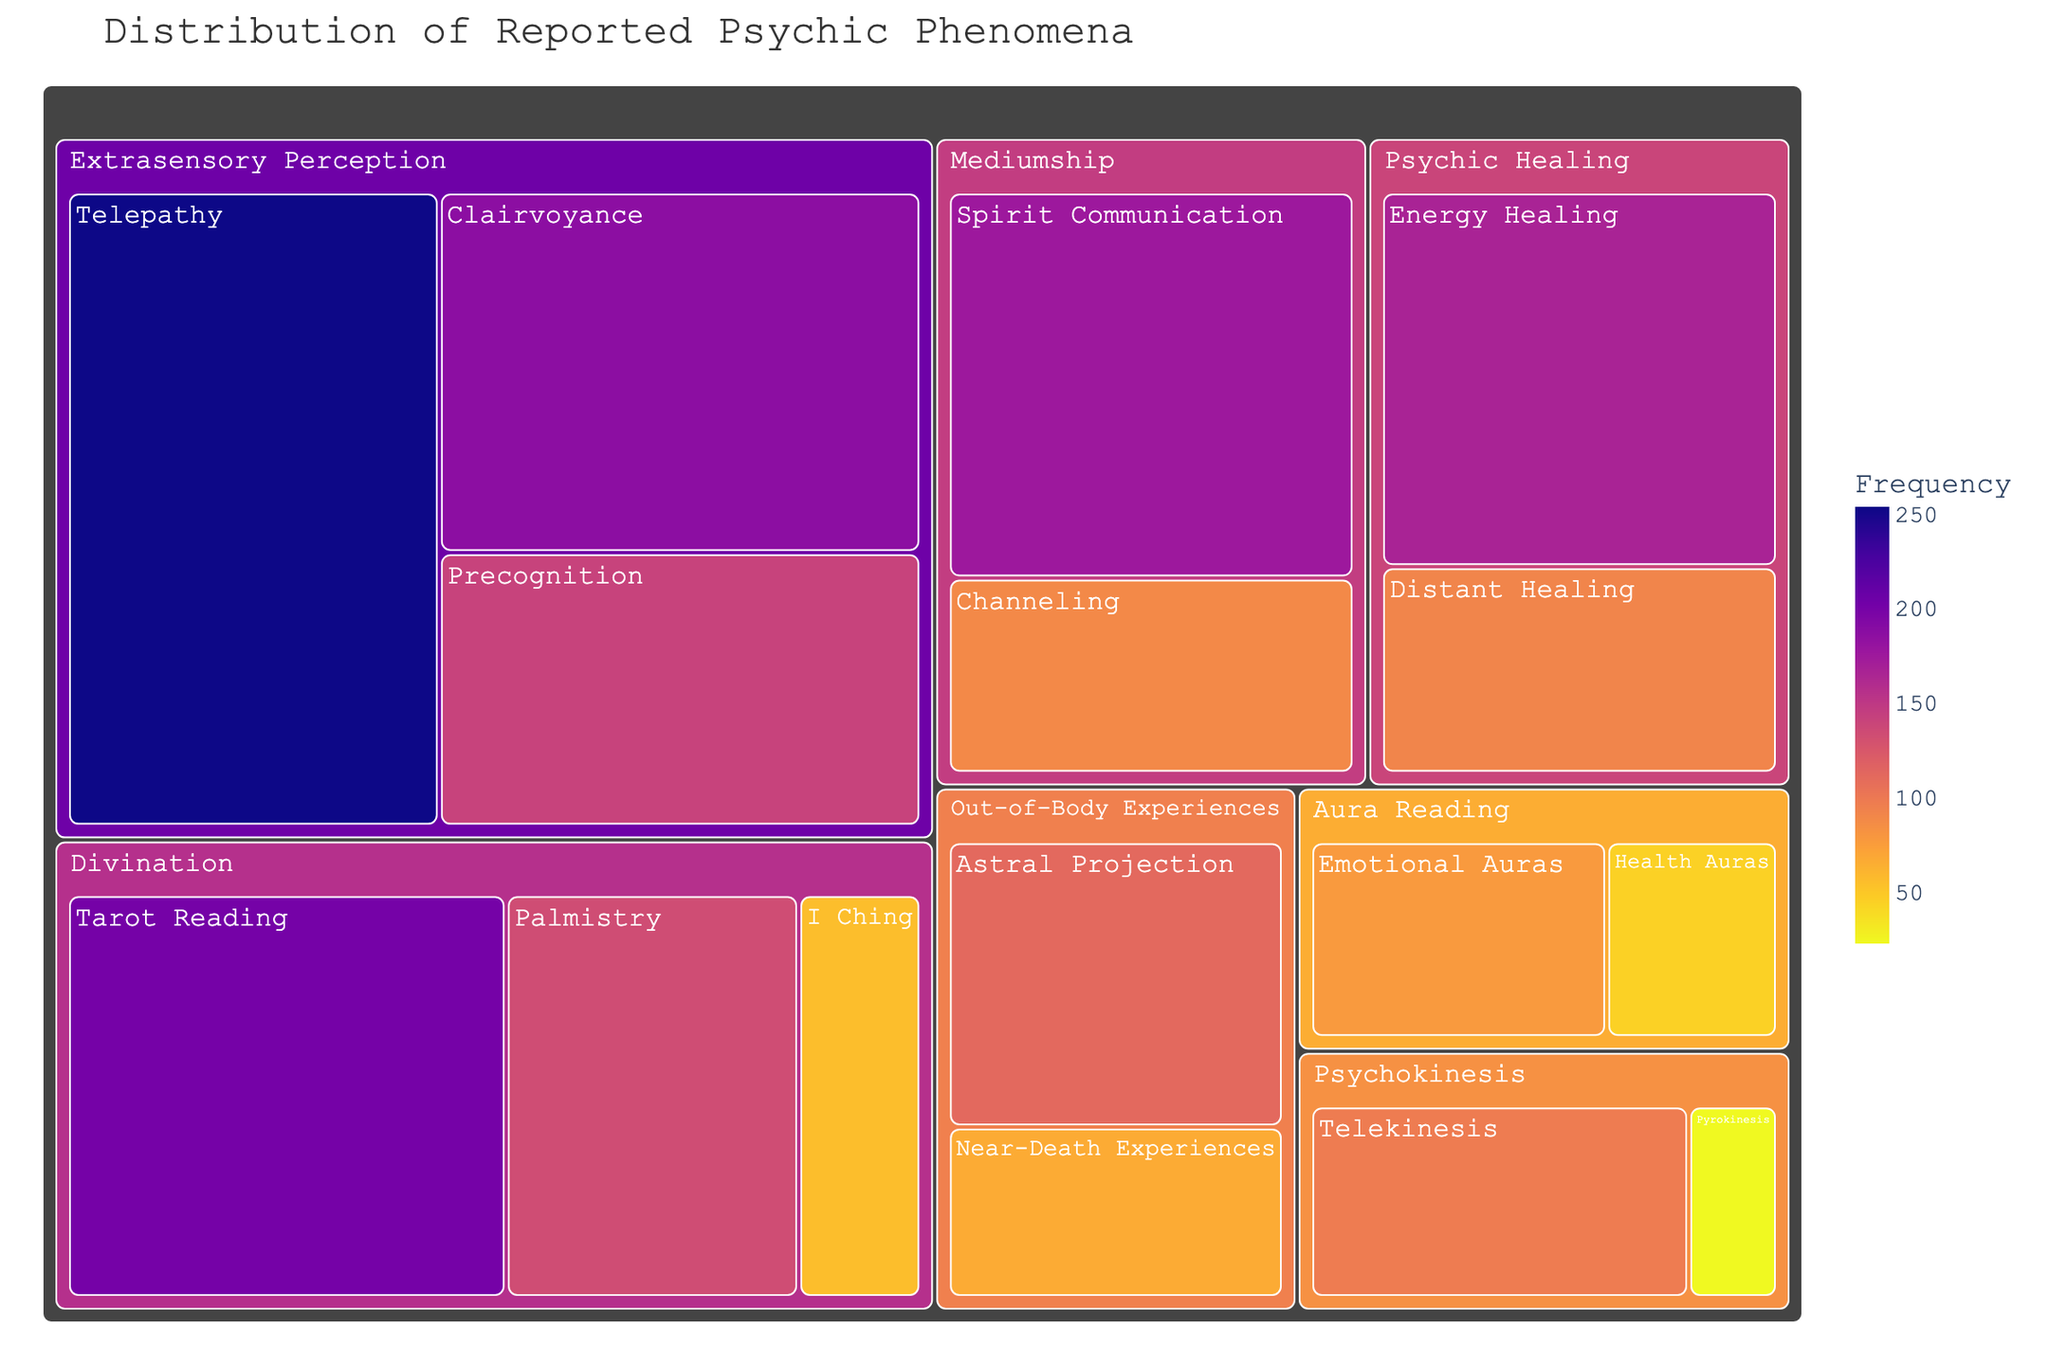What is the title of the treemap? The treemap has a title at the top which says "Distribution of Reported Psychic Phenomena".
Answer: "Distribution of Reported Psychic Phenomena" Which subtype under Extrasensory Perception has the highest frequency? Under the category of Extrasensory Perception, the subtypes are Telepathy, Clairvoyance, and Precognition. Telepathy has the highest frequency of 254.
Answer: Telepathy How many subtypes are present under the category Divination? The treemap shows that Divination has three subtypes: Tarot Reading, Palmistry, and I Ching.
Answer: 3 What is the combined frequency of Psychic Healing subtypes? Psychic Healing includes Energy Healing with a frequency of 167 and Distant Healing with a frequency of 92. Adding these gives 167 + 92 = 259.
Answer: 259 Is the frequency of Telepathy greater than the combined frequency of all Aura Reading subtypes? Telepathy has a frequency of 254. Aura Reading includes Emotional Auras (78) and Health Auras (45). Their combined frequency is 78 + 45 = 123. Since 254 > 123, Telepathy has a greater frequency.
Answer: Yes Which has a higher frequency, Spirit Communication or Astral Projection? Spirit Communication is a subtype of Mediumship with a frequency of 176, while Astral Projection is under Out-of-Body Experiences with a frequency of 112. 176 > 112.
Answer: Spirit Communication What is the frequency difference between Clairvoyance and Palmistry? Clairvoyance has a frequency of 187, while Palmistry has 134. The difference is 187 - 134 = 53.
Answer: 53 What type has the least frequently reported psychic phenomenon, and what is it? By looking at the frequencies, Pyrokinesis (23) under Psychokinesis has the lowest reported frequency of all subtypes.
Answer: Pyrokinesis How do the frequencies of Near-Death Experiences and Distant Healing compare? Near-Death Experiences has a frequency of 67, and Distant Healing has a frequency of 92. Since 92 > 67, Distant Healing has a higher frequency.
Answer: Distant Healing What is the total frequency of all Extrasensory Perception subtypes combined? Adding the frequencies for all Extrasensory Perception subtypes: Telepathy (254), Clairvoyance (187), and Precognition (142). The total is 254 + 187 + 142 = 583.
Answer: 583 